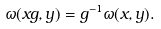Convert formula to latex. <formula><loc_0><loc_0><loc_500><loc_500>\omega ( x g , y ) = g ^ { - 1 } \omega ( x , y ) .</formula> 